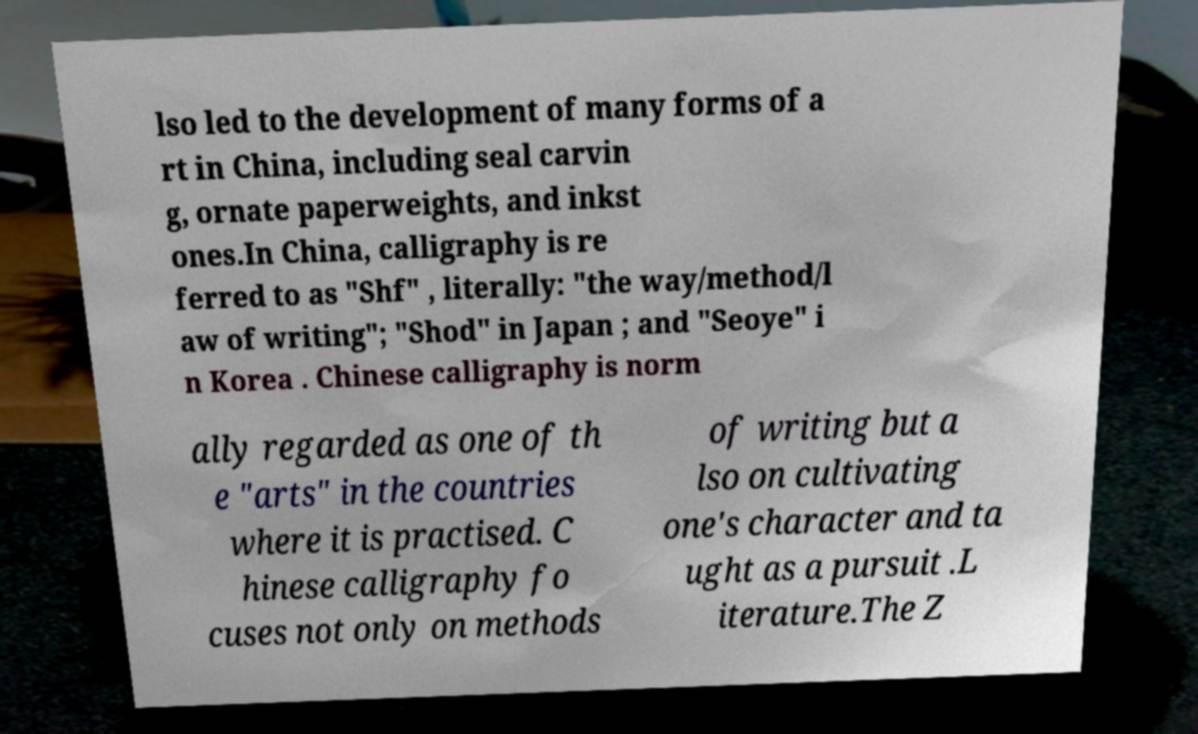Can you read and provide the text displayed in the image?This photo seems to have some interesting text. Can you extract and type it out for me? lso led to the development of many forms of a rt in China, including seal carvin g, ornate paperweights, and inkst ones.In China, calligraphy is re ferred to as "Shf" , literally: "the way/method/l aw of writing"; "Shod" in Japan ; and "Seoye" i n Korea . Chinese calligraphy is norm ally regarded as one of th e "arts" in the countries where it is practised. C hinese calligraphy fo cuses not only on methods of writing but a lso on cultivating one's character and ta ught as a pursuit .L iterature.The Z 